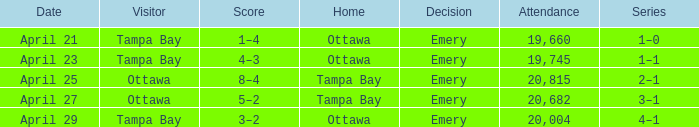What is the date of the match when attendance exceeds 20,682? April 25. 